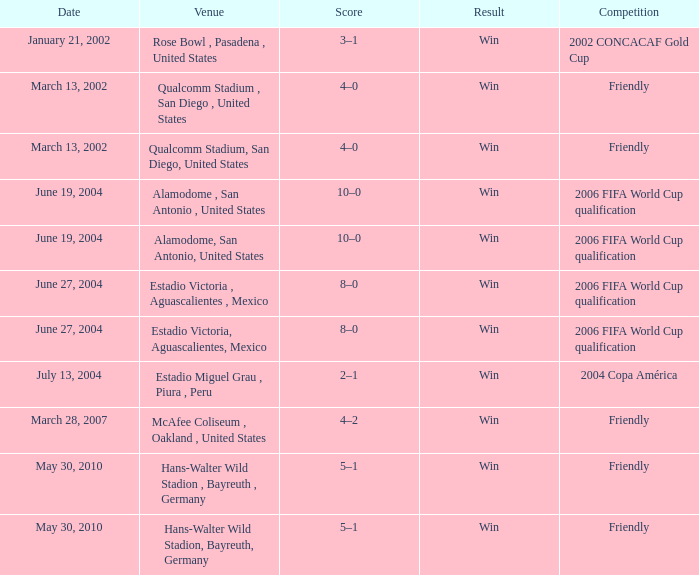What date has 2006 fifa world cup qualification as the competition, and alamodome, san antonio, united States as the venue? June 19, 2004, June 19, 2004. 